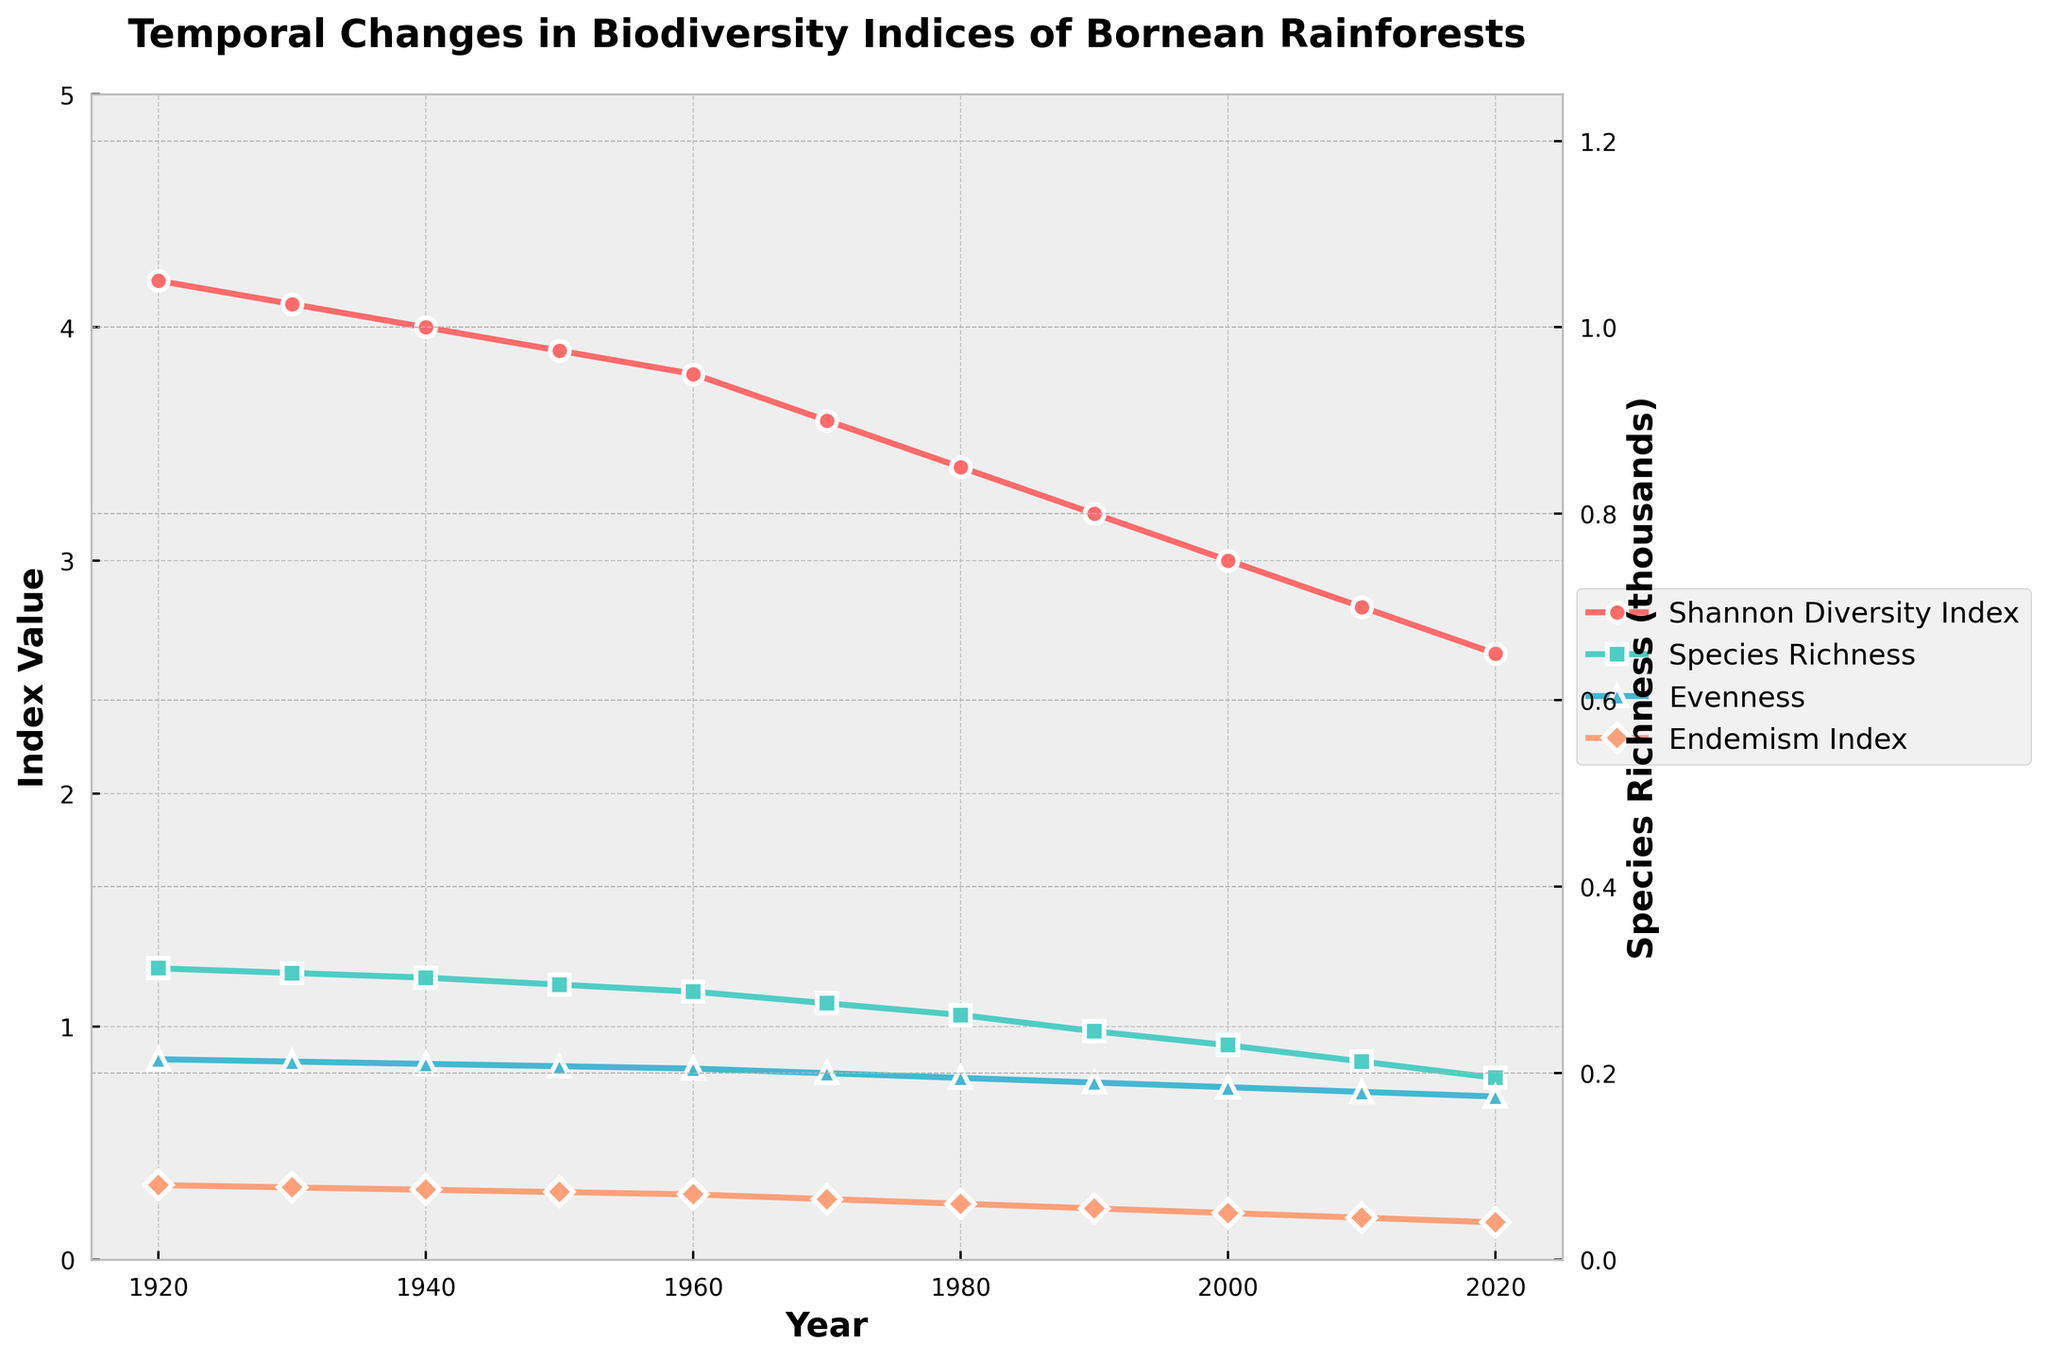What does the trend in the Shannon Diversity Index show over the last century? The Shannon Diversity Index has a downward trend from 1920 to 2020, indicating a decrease in biodiversity over time.
Answer: Downward trend Which biodiversity index has the steepest decline over the century? The Species Richness appears to decline the most dramatically from around 1250 species in 1920 to 780 species in 2020.
Answer: Species Richness Between which decades does the evenness index show the most significant drop, and what are the values? The most significant drop in the evenness index occurs between the decades 1960 (0.82) and 1970 (0.80), a difference of 0.02.
Answer: 1960 and 1970, 0.02 Compare the species richness in 1920 to the species richness in 2020 in terms of percentage decrease. The species richness in 1920 is 1250, and in 2020 it is 780. The percentage decrease is calculated as ((1250 - 780) / 1250) * 100 = 37.6%.
Answer: 37.6% For which year does the endemism index hit its lowest value? The endemism index hits its lowest value of 0.16 in 2020.
Answer: 2020 What is the average Shannon Diversity Index for the first half (1920-1970) and the second half (1980-2020) of the century? For 1920-1970, the average is (4.2 + 4.1 + 4.0 + 3.9 + 3.8 + 3.6) / 6 = 3.933. For 1980-2020, the average is (3.4 + 3.2 + 3.0 + 2.8 + 2.6) / 5 = 3.0.
Answer: 3.933 and 3.0 Which year shows an equal value for both the evenness index and the endemism index? In 1920, both the evenness index and the endemism index have equal values of 0.86 and 0.32, respectively.
Answer: Neither year has equal values for both indexes How does the Species Richness value change in numerical terms from 1950 to 1980? The Species Richness decreases from 1180 in 1950 to 1050 in 1980, a change of 130.
Answer: Decreases by 130 How does the line for the evenness index visually compare to the other lines? The evenness index shows a more gradual, less steep decline compared to the Shannon Diversity Index and Species Richness lines.
Answer: Gradual decline 